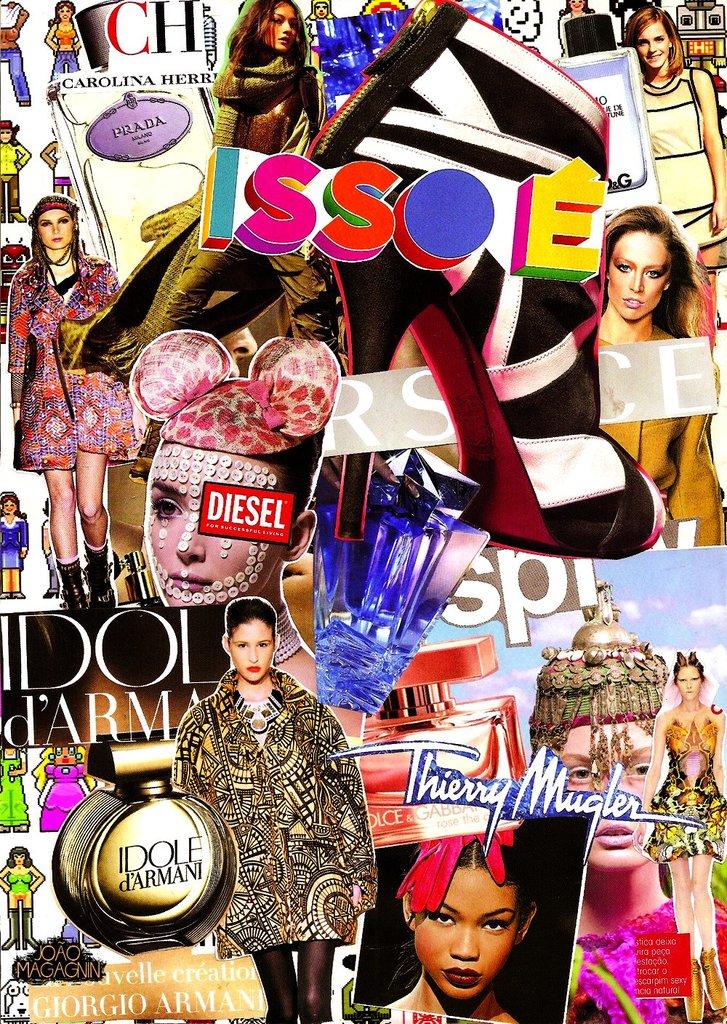What brands are on the collage?
Make the answer very short. Diesel. What is the magazine called?
Your answer should be very brief. Issoe. 